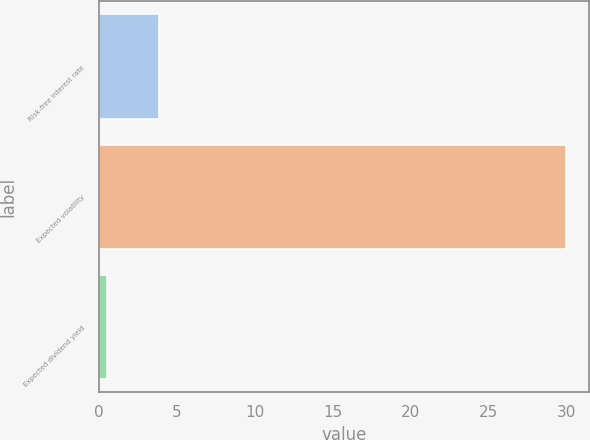<chart> <loc_0><loc_0><loc_500><loc_500><bar_chart><fcel>Risk-free interest rate<fcel>Expected volatility<fcel>Expected dividend yield<nl><fcel>3.84<fcel>30<fcel>0.52<nl></chart> 